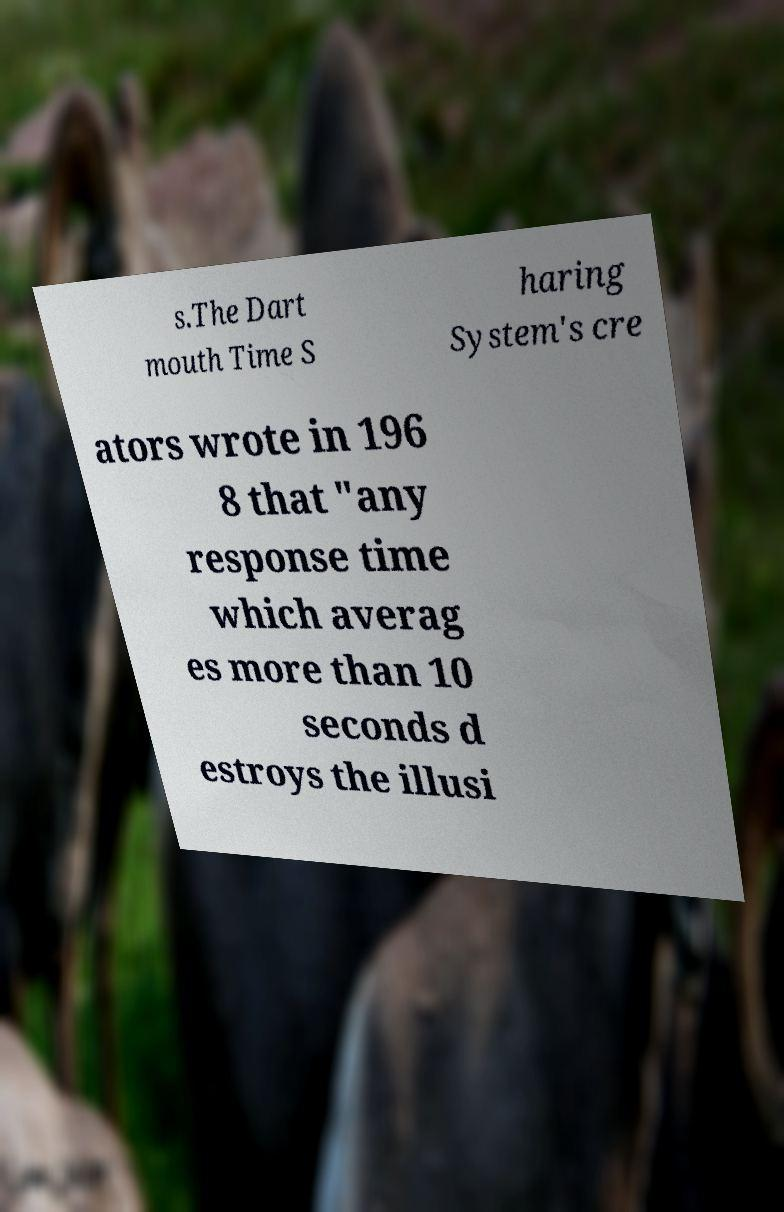There's text embedded in this image that I need extracted. Can you transcribe it verbatim? s.The Dart mouth Time S haring System's cre ators wrote in 196 8 that "any response time which averag es more than 10 seconds d estroys the illusi 